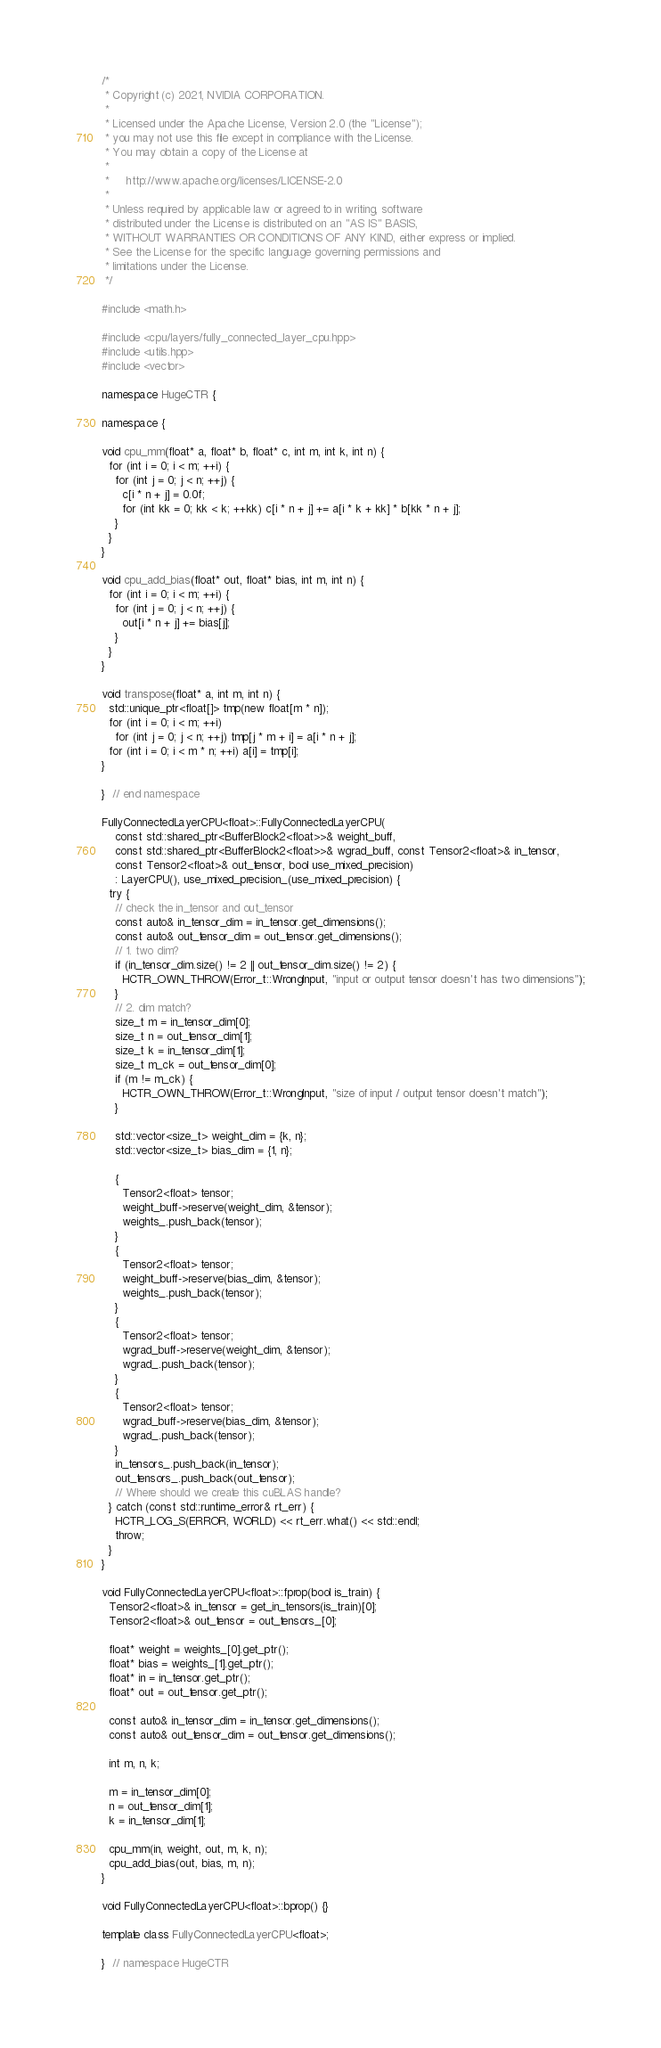Convert code to text. <code><loc_0><loc_0><loc_500><loc_500><_C++_>/*
 * Copyright (c) 2021, NVIDIA CORPORATION.
 *
 * Licensed under the Apache License, Version 2.0 (the "License");
 * you may not use this file except in compliance with the License.
 * You may obtain a copy of the License at
 *
 *     http://www.apache.org/licenses/LICENSE-2.0
 *
 * Unless required by applicable law or agreed to in writing, software
 * distributed under the License is distributed on an "AS IS" BASIS,
 * WITHOUT WARRANTIES OR CONDITIONS OF ANY KIND, either express or implied.
 * See the License for the specific language governing permissions and
 * limitations under the License.
 */

#include <math.h>

#include <cpu/layers/fully_connected_layer_cpu.hpp>
#include <utils.hpp>
#include <vector>

namespace HugeCTR {

namespace {

void cpu_mm(float* a, float* b, float* c, int m, int k, int n) {
  for (int i = 0; i < m; ++i) {
    for (int j = 0; j < n; ++j) {
      c[i * n + j] = 0.0f;
      for (int kk = 0; kk < k; ++kk) c[i * n + j] += a[i * k + kk] * b[kk * n + j];
    }
  }
}

void cpu_add_bias(float* out, float* bias, int m, int n) {
  for (int i = 0; i < m; ++i) {
    for (int j = 0; j < n; ++j) {
      out[i * n + j] += bias[j];
    }
  }
}

void transpose(float* a, int m, int n) {
  std::unique_ptr<float[]> tmp(new float[m * n]);
  for (int i = 0; i < m; ++i)
    for (int j = 0; j < n; ++j) tmp[j * m + i] = a[i * n + j];
  for (int i = 0; i < m * n; ++i) a[i] = tmp[i];
}

}  // end namespace

FullyConnectedLayerCPU<float>::FullyConnectedLayerCPU(
    const std::shared_ptr<BufferBlock2<float>>& weight_buff,
    const std::shared_ptr<BufferBlock2<float>>& wgrad_buff, const Tensor2<float>& in_tensor,
    const Tensor2<float>& out_tensor, bool use_mixed_precision)
    : LayerCPU(), use_mixed_precision_(use_mixed_precision) {
  try {
    // check the in_tensor and out_tensor
    const auto& in_tensor_dim = in_tensor.get_dimensions();
    const auto& out_tensor_dim = out_tensor.get_dimensions();
    // 1. two dim?
    if (in_tensor_dim.size() != 2 || out_tensor_dim.size() != 2) {
      HCTR_OWN_THROW(Error_t::WrongInput, "input or output tensor doesn't has two dimensions");
    }
    // 2. dim match?
    size_t m = in_tensor_dim[0];
    size_t n = out_tensor_dim[1];
    size_t k = in_tensor_dim[1];
    size_t m_ck = out_tensor_dim[0];
    if (m != m_ck) {
      HCTR_OWN_THROW(Error_t::WrongInput, "size of input / output tensor doesn't match");
    }

    std::vector<size_t> weight_dim = {k, n};
    std::vector<size_t> bias_dim = {1, n};

    {
      Tensor2<float> tensor;
      weight_buff->reserve(weight_dim, &tensor);
      weights_.push_back(tensor);
    }
    {
      Tensor2<float> tensor;
      weight_buff->reserve(bias_dim, &tensor);
      weights_.push_back(tensor);
    }
    {
      Tensor2<float> tensor;
      wgrad_buff->reserve(weight_dim, &tensor);
      wgrad_.push_back(tensor);
    }
    {
      Tensor2<float> tensor;
      wgrad_buff->reserve(bias_dim, &tensor);
      wgrad_.push_back(tensor);
    }
    in_tensors_.push_back(in_tensor);
    out_tensors_.push_back(out_tensor);
    // Where should we create this cuBLAS handle?
  } catch (const std::runtime_error& rt_err) {
    HCTR_LOG_S(ERROR, WORLD) << rt_err.what() << std::endl;
    throw;
  }
}

void FullyConnectedLayerCPU<float>::fprop(bool is_train) {
  Tensor2<float>& in_tensor = get_in_tensors(is_train)[0];
  Tensor2<float>& out_tensor = out_tensors_[0];

  float* weight = weights_[0].get_ptr();
  float* bias = weights_[1].get_ptr();
  float* in = in_tensor.get_ptr();
  float* out = out_tensor.get_ptr();

  const auto& in_tensor_dim = in_tensor.get_dimensions();
  const auto& out_tensor_dim = out_tensor.get_dimensions();

  int m, n, k;

  m = in_tensor_dim[0];
  n = out_tensor_dim[1];
  k = in_tensor_dim[1];

  cpu_mm(in, weight, out, m, k, n);
  cpu_add_bias(out, bias, m, n);
}

void FullyConnectedLayerCPU<float>::bprop() {}

template class FullyConnectedLayerCPU<float>;

}  // namespace HugeCTR
</code> 